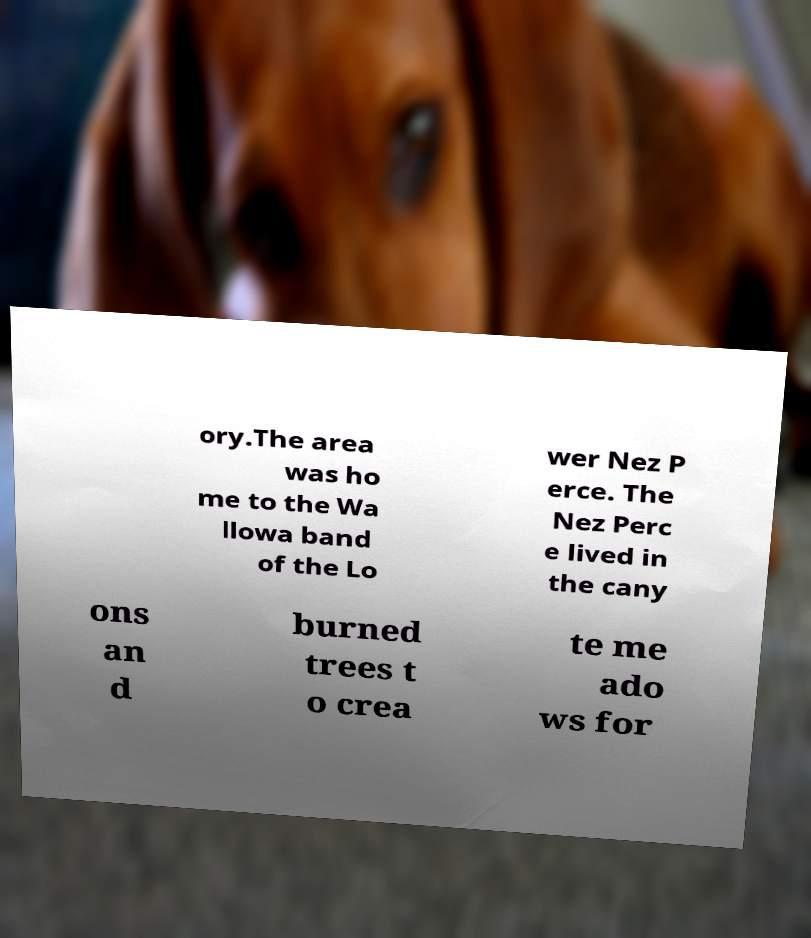Could you assist in decoding the text presented in this image and type it out clearly? ory.The area was ho me to the Wa llowa band of the Lo wer Nez P erce. The Nez Perc e lived in the cany ons an d burned trees t o crea te me ado ws for 